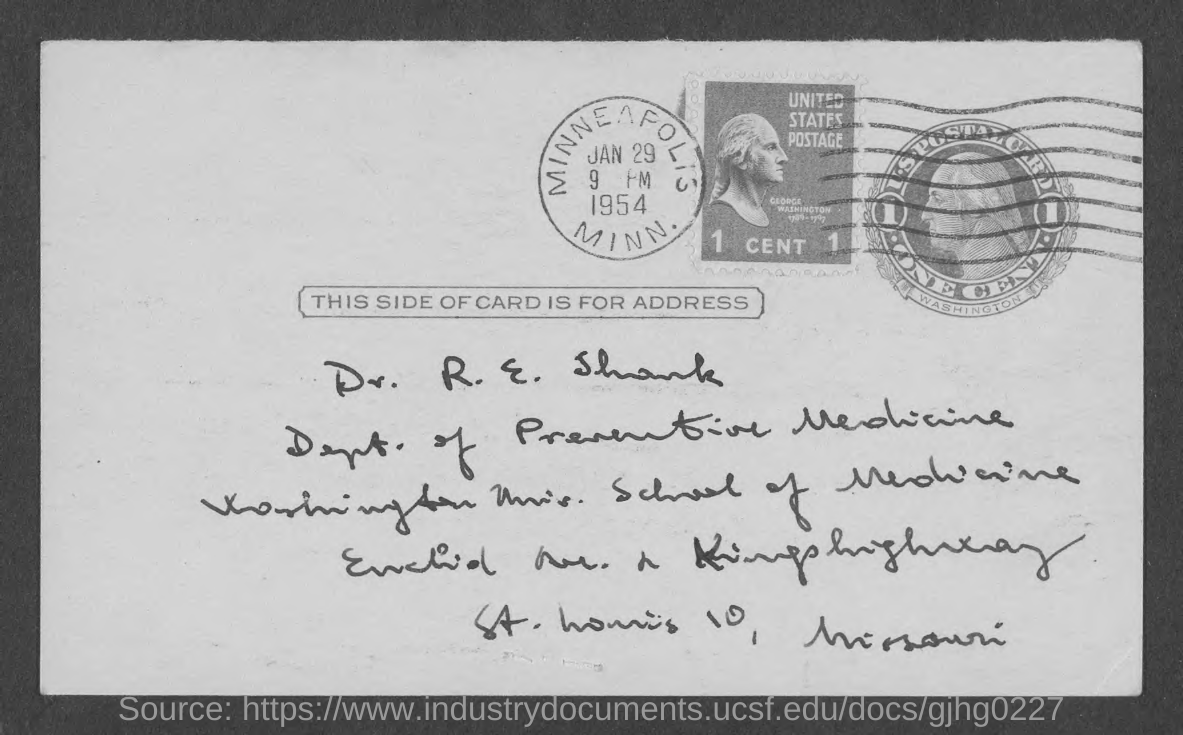Outline some significant characteristics in this image. Dr. R. E. Shank is part of the Department of Preventive Medicine. The card is addressed to Dr. R. E. Shank. The place mentioned on the stamp is MINN... 